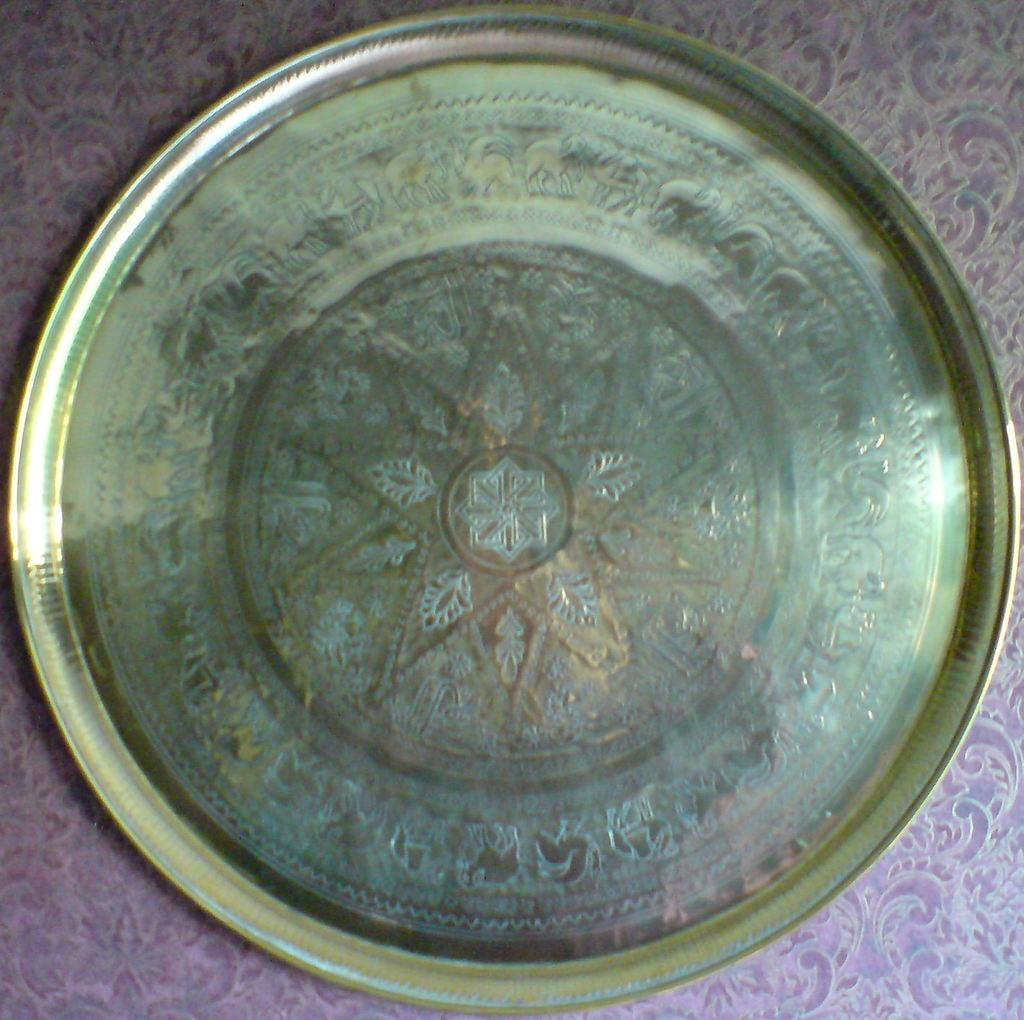What is the material of the plate that is visible in the image? The plate is made of silver. Where is the silver plate located in the image? The silver plate is placed on a table. What type of basket is used for learning in the image? There is no basket or learning activity present in the image. 